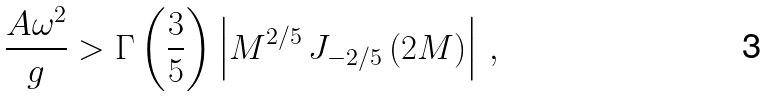Convert formula to latex. <formula><loc_0><loc_0><loc_500><loc_500>\frac { A \omega ^ { 2 } } { g } > \Gamma \left ( \frac { 3 } { 5 } \right ) \left | M ^ { 2 / 5 } \, J _ { - 2 / 5 } \left ( 2 M \right ) \right | \, ,</formula> 